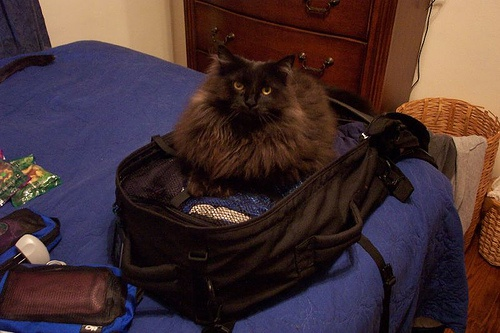Describe the objects in this image and their specific colors. I can see suitcase in black, maroon, navy, and purple tones, bed in black, navy, and purple tones, cat in black, maroon, and brown tones, and backpack in black, navy, and tan tones in this image. 